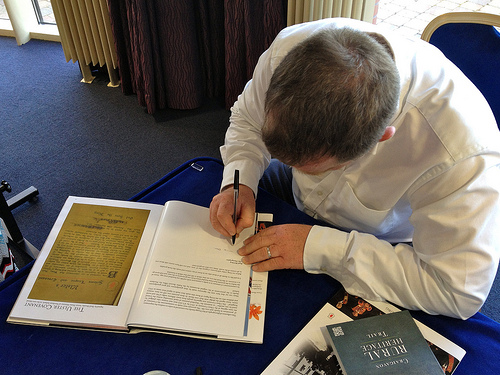<image>
Is the man above the notebook? Yes. The man is positioned above the notebook in the vertical space, higher up in the scene. 